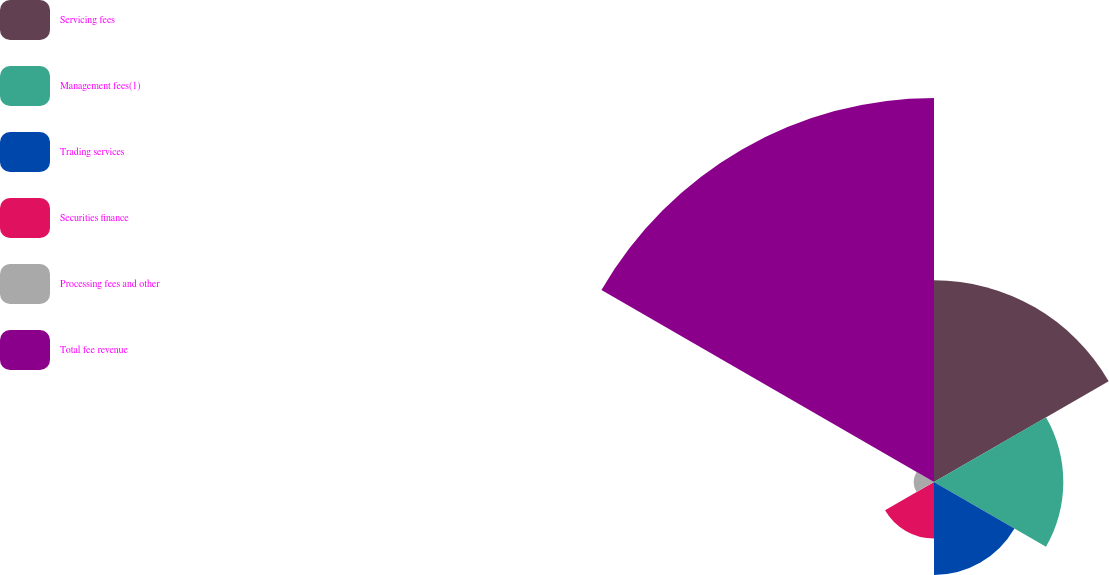<chart> <loc_0><loc_0><loc_500><loc_500><pie_chart><fcel>Servicing fees<fcel>Management fees(1)<fcel>Trading services<fcel>Securities finance<fcel>Processing fees and other<fcel>Total fee revenue<nl><fcel>22.8%<fcel>14.62%<fcel>10.5%<fcel>6.39%<fcel>2.28%<fcel>43.41%<nl></chart> 